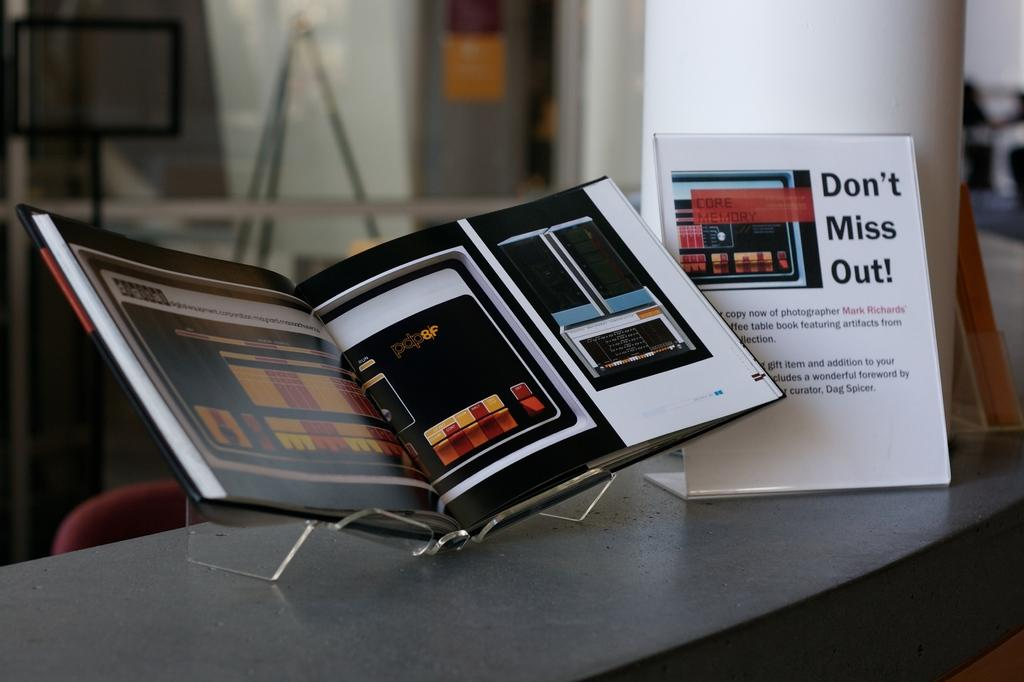<image>
Provide a brief description of the given image. a paper next to a book that says 'don't miss out!' on it 